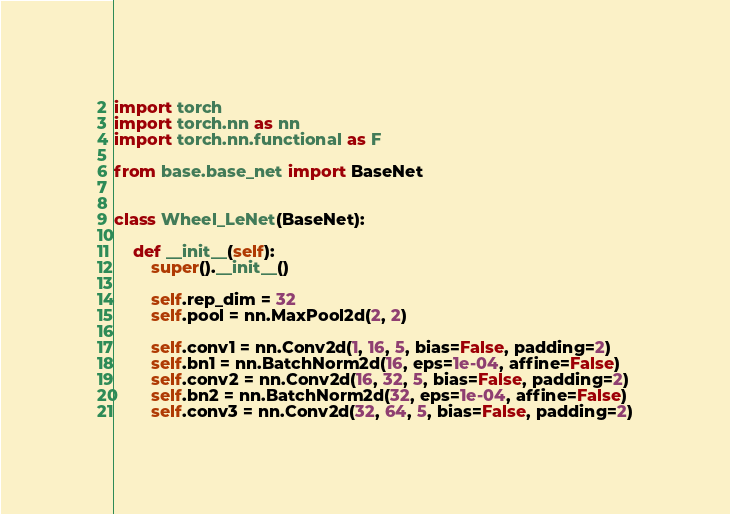Convert code to text. <code><loc_0><loc_0><loc_500><loc_500><_Python_>import torch
import torch.nn as nn
import torch.nn.functional as F

from base.base_net import BaseNet


class Wheel_LeNet(BaseNet):

    def __init__(self):
        super().__init__()

        self.rep_dim = 32
        self.pool = nn.MaxPool2d(2, 2)

        self.conv1 = nn.Conv2d(1, 16, 5, bias=False, padding=2)
        self.bn1 = nn.BatchNorm2d(16, eps=1e-04, affine=False)
        self.conv2 = nn.Conv2d(16, 32, 5, bias=False, padding=2)
        self.bn2 = nn.BatchNorm2d(32, eps=1e-04, affine=False)
        self.conv3 = nn.Conv2d(32, 64, 5, bias=False, padding=2)</code> 